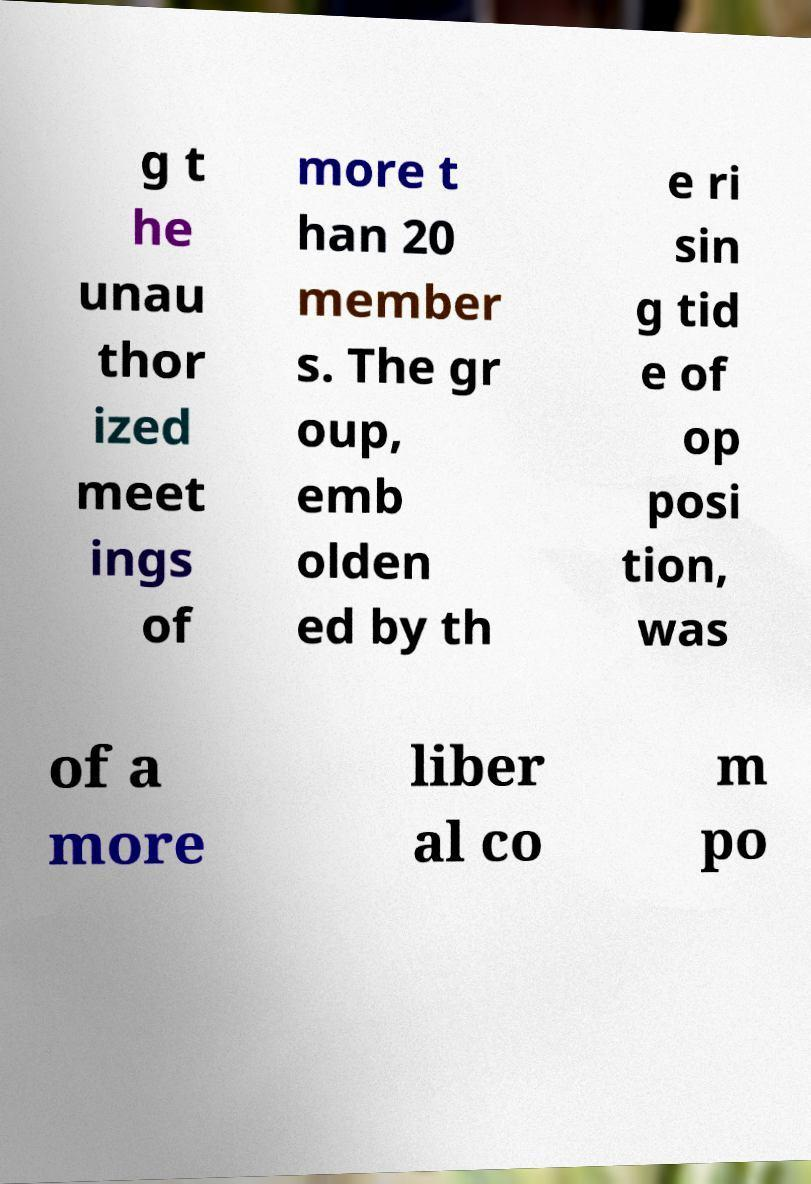Could you assist in decoding the text presented in this image and type it out clearly? g t he unau thor ized meet ings of more t han 20 member s. The gr oup, emb olden ed by th e ri sin g tid e of op posi tion, was of a more liber al co m po 